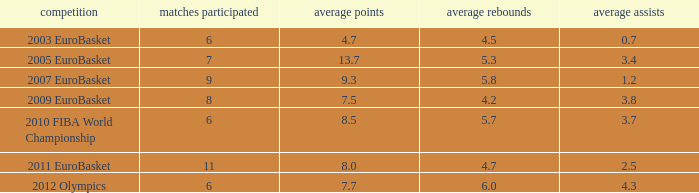How many assists per game in the tournament 2010 fiba world championship? 3.7. 